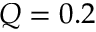<formula> <loc_0><loc_0><loc_500><loc_500>Q = 0 . 2</formula> 